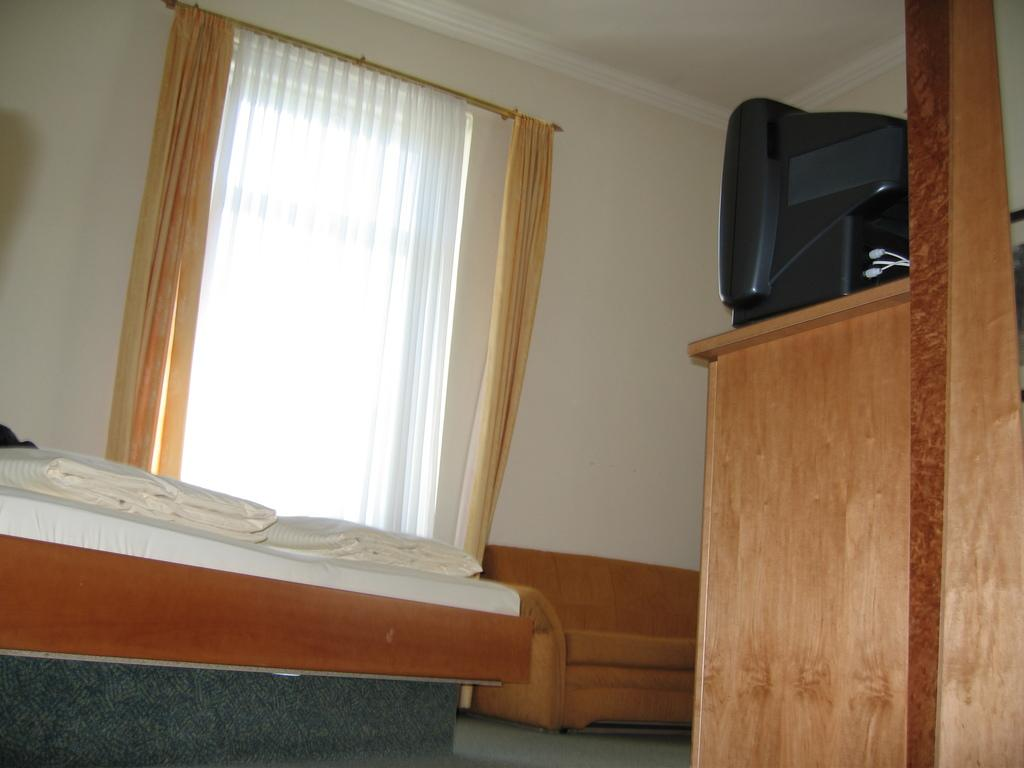What piece of furniture is present in the image? There is a bed in the image. What is covering the bed? The bed has blankets on it. What type of window treatment is visible in the image? There are curtains in the image. What electronic device can be seen on the right side of the image? There is a television on the right side of the image. What time of day is it in the image, and how hot is it? The provided facts do not give any information about the time of day or temperature, so we cannot determine the time or temperature from the image. 